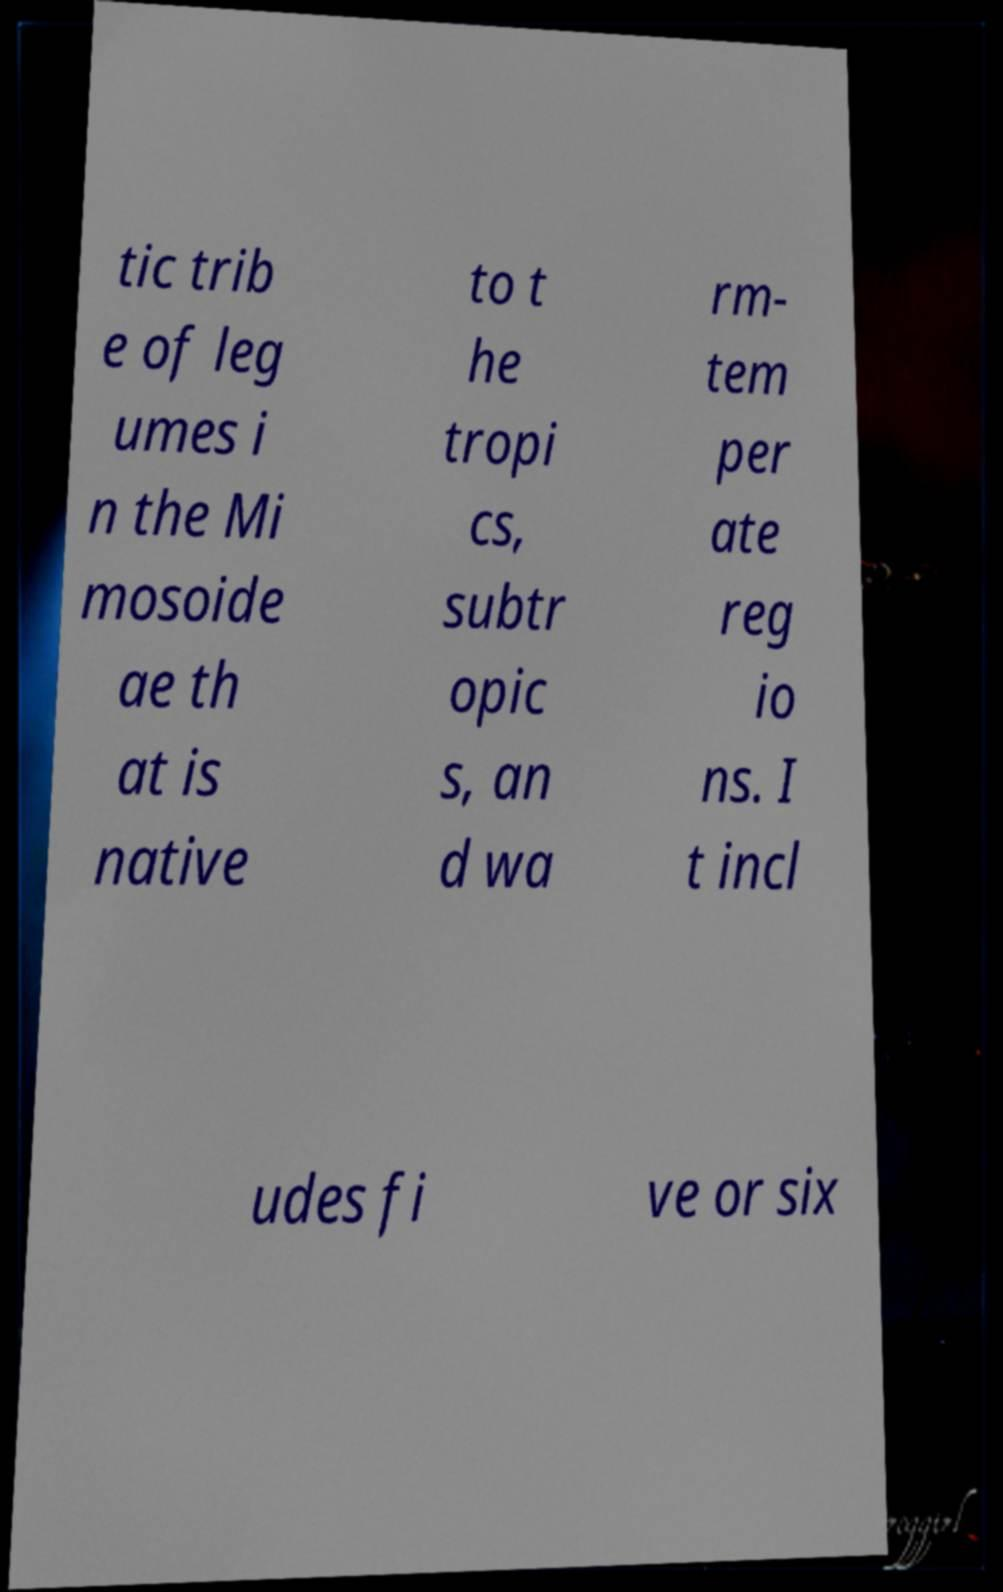I need the written content from this picture converted into text. Can you do that? tic trib e of leg umes i n the Mi mosoide ae th at is native to t he tropi cs, subtr opic s, an d wa rm- tem per ate reg io ns. I t incl udes fi ve or six 